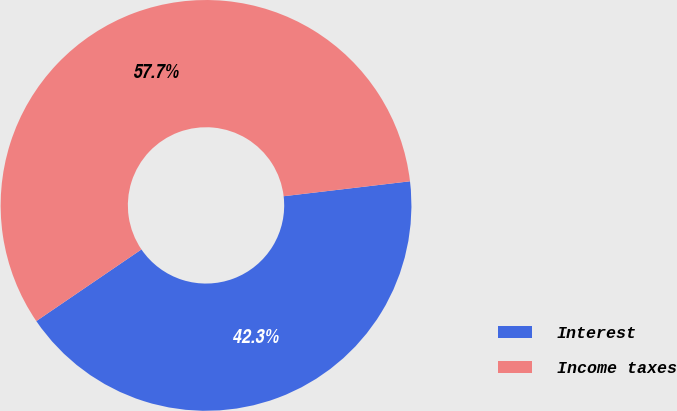<chart> <loc_0><loc_0><loc_500><loc_500><pie_chart><fcel>Interest<fcel>Income taxes<nl><fcel>42.35%<fcel>57.65%<nl></chart> 